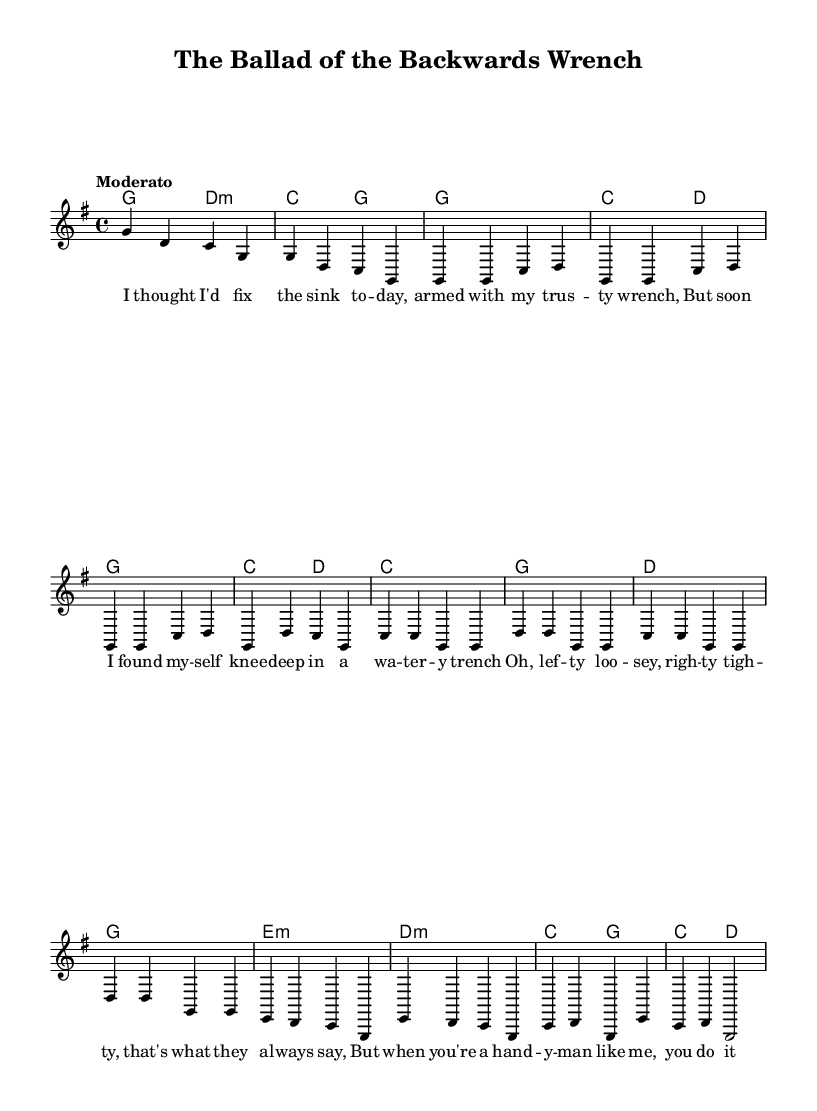What is the key signature of this music? The key signature is G major, which has one sharp (F#). This is evident at the beginning of the sheet music where the key signature is indicated.
Answer: G major What is the time signature of this music? The time signature is 4/4, which is shown at the beginning of the score. It indicates that there are four beats per measure and the quarter note gets one beat.
Answer: 4/4 What is the tempo marking for this piece? The tempo marking is "Moderato," which is placed at the beginning of the sheet music. This indicates a moderate speed for the piece.
Answer: Moderato How many measures are in the verse section? The verse section consists of four measures. This can be determined by counting the number of notated measures in the "Verse 1" section of the melody.
Answer: Four What is the primary theme of this ballad? The primary theme revolves around a DIY disaster involving a sink and a wrench, as indicated by the lyrics in the verse. This is apparent from the wording and context of the lyrics provided.
Answer: DIY disaster Which section contains the repeated lyrics? The chorus contains the repeated lyrics as it follows a consistent melodic structure with the same words repeated each time. This is a common feature of folk songs, and the lyrics are marked as "Chorus."
Answer: Chorus 